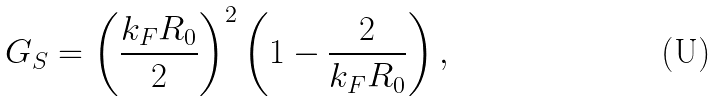<formula> <loc_0><loc_0><loc_500><loc_500>G _ { S } = \left ( \frac { k _ { F } R _ { 0 } } { 2 } \right ) ^ { 2 } \left ( 1 - \frac { 2 } { k _ { F } R _ { 0 } } \right ) ,</formula> 